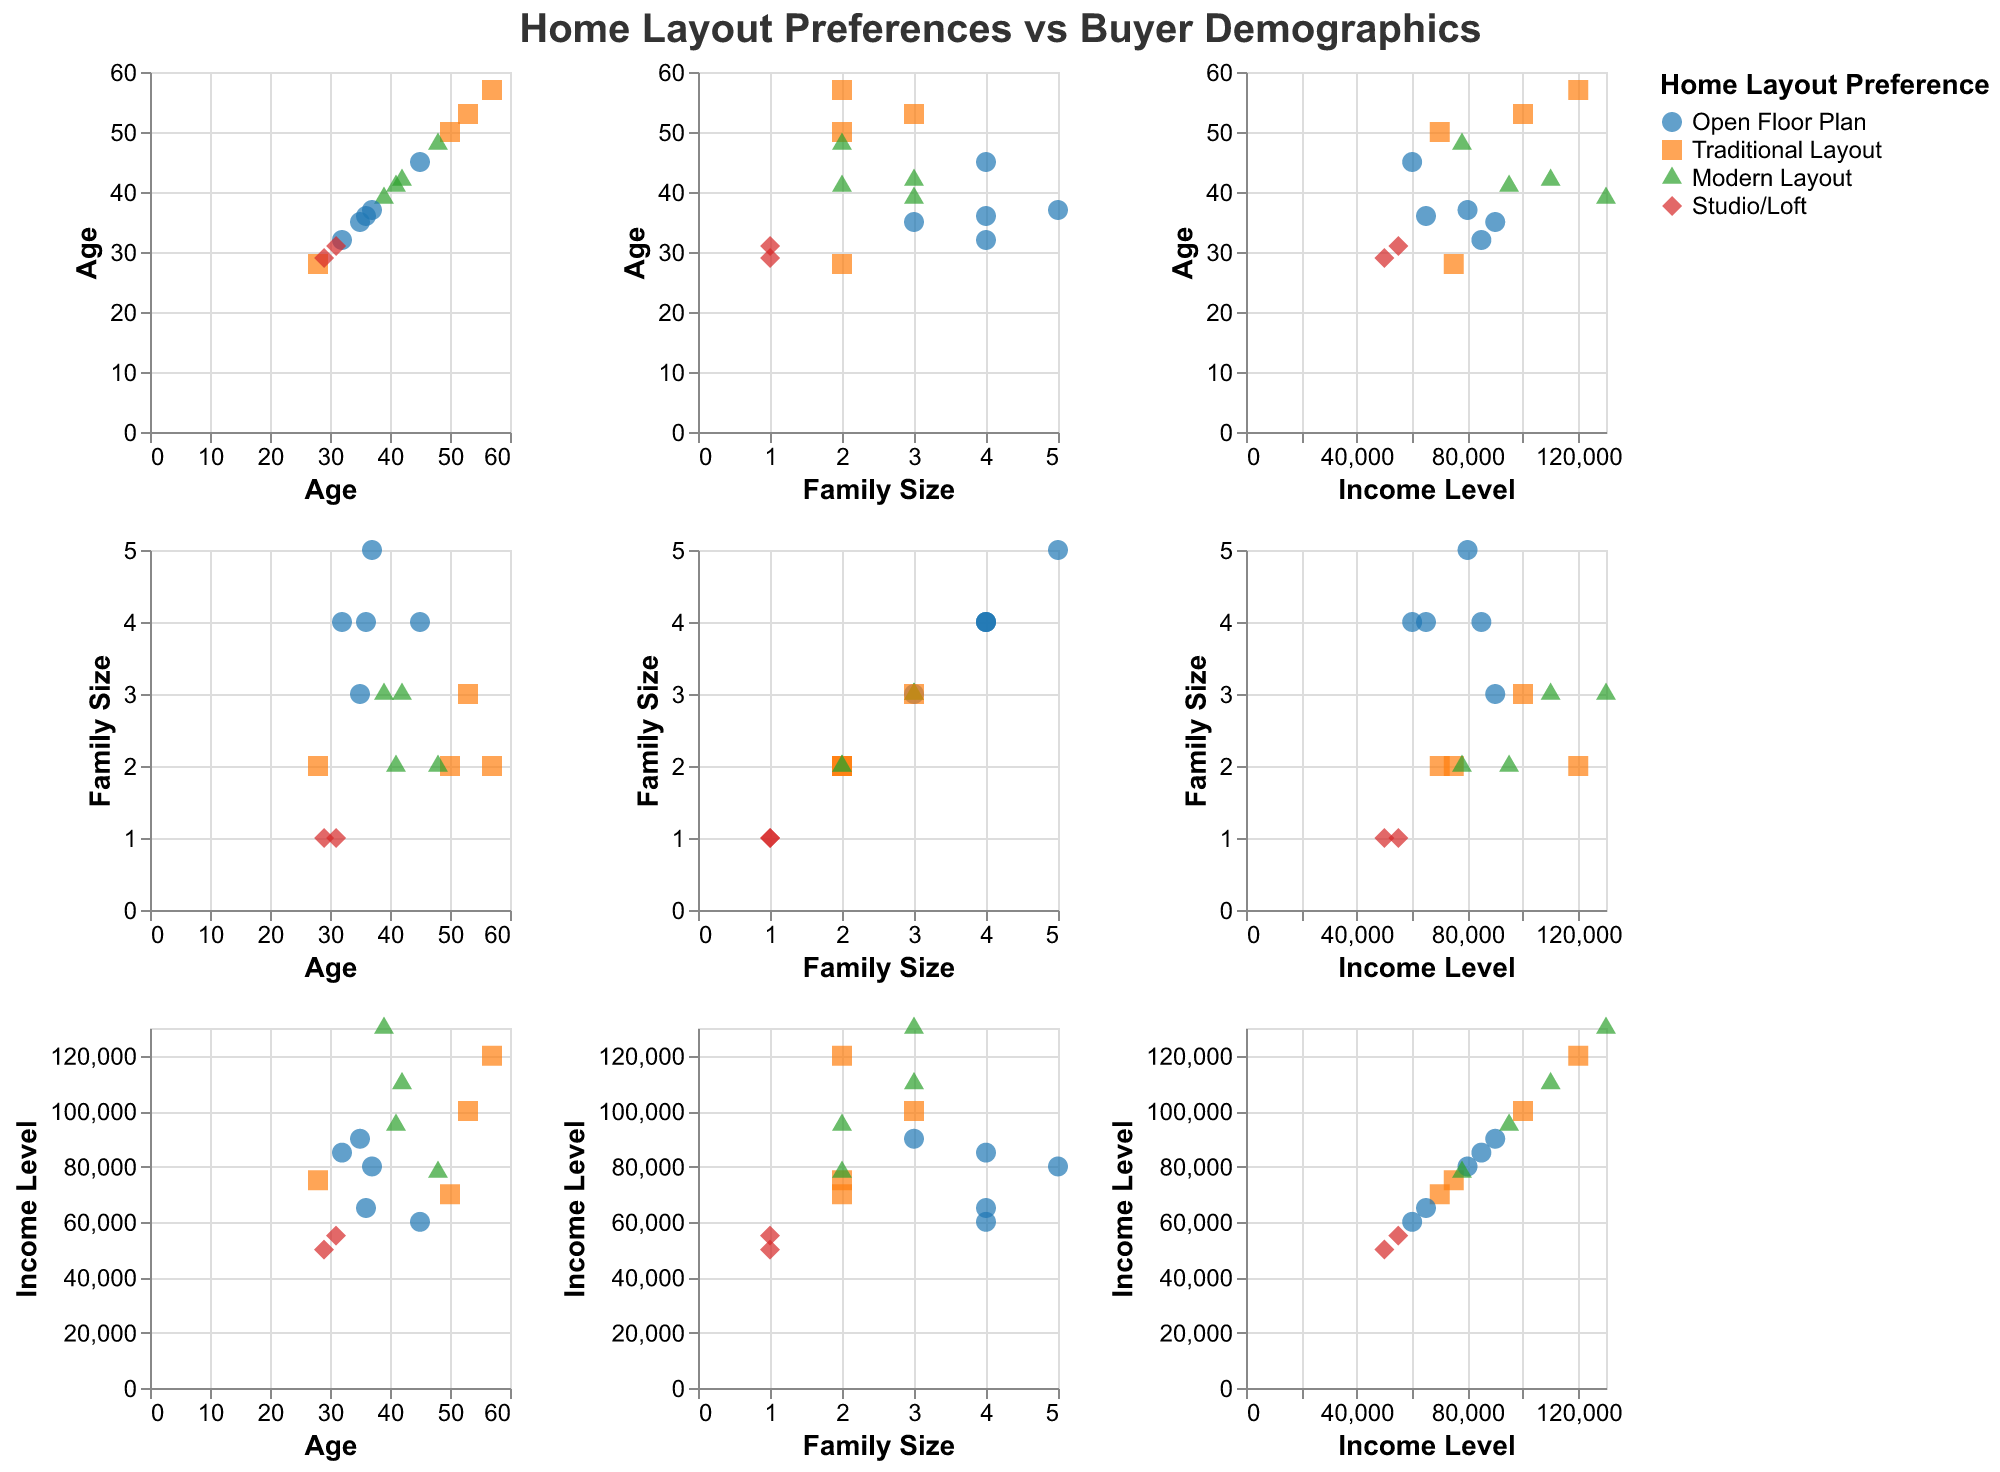What are the different home layout preferences shown in the figure? The figure legend lists the different home layout preferences as Open Floor Plan, Traditional Layout, Modern Layout, and Studio/Loft.
Answer: Open Floor Plan, Traditional Layout, Modern Layout, Studio/Loft Which age group has the highest number of preferences for Modern Layout? To find the age group with the highest prevalence for Modern Layout, look for data points marked with the triangle shape (as indicated in the legend) in scatter plots involving age. The age groups 39, 41, 42, and 48 all have preferences for Modern Layout.
Answer: 39, 41, 42, 48 What is the range of family sizes that prefer an Open Floor Plan? For Open Floor Plan, observe the scatterplot points that are marked with circles. The family sizes range from 2 to 5 for those who prefer Open Floor Plan.
Answer: 2 to 5 Which occupation has the highest income level that prefers a Traditional Layout? First, identify the income levels of points marked with squares in scatter plots involving "Income Level." The highest income level preferring Traditional Layout is from the occupation "Doctor" with an income of $120,000.
Answer: Doctor Are there any correlations between income level and age for those who prefer Studio/Loft? Look at the scatter plots containing income level and age for points marked with a diamond shape. The ages 29 and 31 both show similar lower income levels ($50,000 and $55,000), suggesting younger buyers preferring Studio/Loft tend to have lower income.
Answer: Younger buyers with lower income How does family size influence home layout preferences? Evaluate scatter plots involving "Family Size" against home layout preferences. Larger families (4 and 5 members) show a strong preference for Open Floor Plans, while smaller families (1 and 2 members) often prefer Traditional Layouts, Modern Layouts, or Studio/Loft.
Answer: Larger families prefer Open Floor Plans; smaller families prefer diverse layouts Which demographic group is most likely to prefer a Modern Layout? By observing the data points shaped as triangles in the scatter plots, it appears that professions like Lawyers, Architects, Project Managers, and HR Managers, typically aged between 39-48 with varying family sizes, are more inclined towards Modern Layouts.
Answer: Lawyers, Architects, Project Managers, HR Managers, aged 39-48 Are there specific income levels associated with certain home layout preferences? By checking income levels across the scatter plots and correlating with layout preferences, Traditional Layout is associated with both high and mid-income levels ($70,000 to $120,000). Modern Layout and Open Floor Plan span across a wider range, from $60,000 to $130,000. Studio/Loft is associated with the lowest income range ($50,000 to $55,000).
Answer: Traditional Layout: $70,000-$120,000, Modern Layout and Open Floor Plan: $60,000-$130,000, Studio/Loft: $50,000-$55,000 